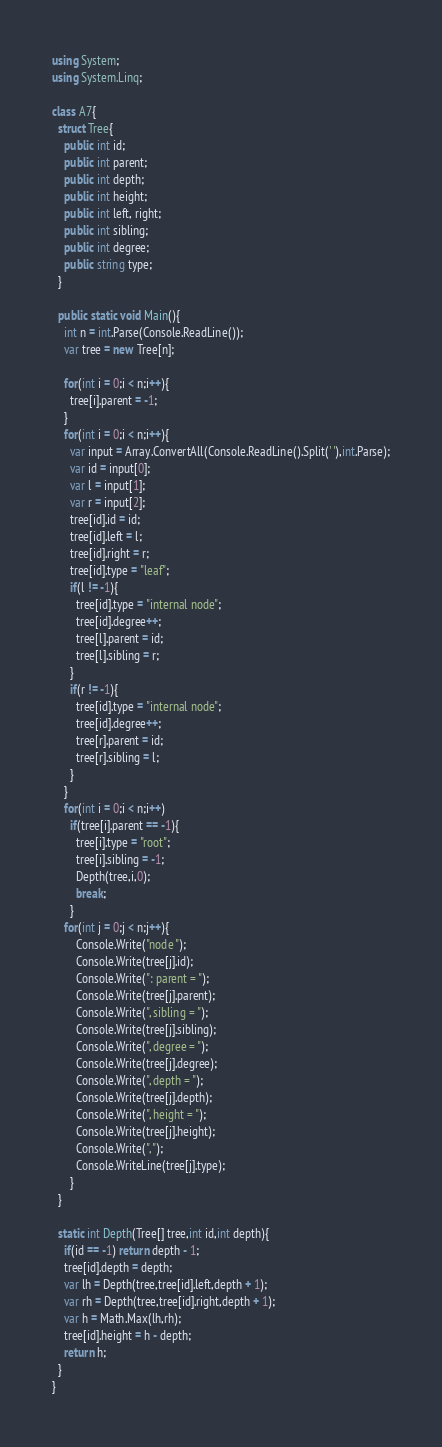Convert code to text. <code><loc_0><loc_0><loc_500><loc_500><_C#_>using System;
using System.Linq;

class A7{
  struct Tree{
    public int id;
    public int parent;
    public int depth;
    public int height;
    public int left, right;
    public int sibling;
    public int degree;
    public string type;
  }

  public static void Main(){
    int n = int.Parse(Console.ReadLine());
    var tree = new Tree[n];

    for(int i = 0;i < n;i++){
      tree[i].parent = -1;
    }
    for(int i = 0;i < n;i++){
      var input = Array.ConvertAll(Console.ReadLine().Split(' '),int.Parse);
      var id = input[0];
      var l = input[1];
      var r = input[2];
      tree[id].id = id;
      tree[id].left = l;
      tree[id].right = r;
      tree[id].type = "leaf";
      if(l != -1){
        tree[id].type = "internal node";
        tree[id].degree++;
        tree[l].parent = id;
        tree[l].sibling = r;
      }
      if(r != -1){
        tree[id].type = "internal node";
        tree[id].degree++;
        tree[r].parent = id;
        tree[r].sibling = l;
      }
    }
    for(int i = 0;i < n;i++)
      if(tree[i].parent == -1){
        tree[i].type = "root";
        tree[i].sibling = -1;
        Depth(tree,i,0);
        break;
      }
    for(int j = 0;j < n;j++){
        Console.Write("node ");
        Console.Write(tree[j].id);
        Console.Write(": parent = ");
        Console.Write(tree[j].parent);
        Console.Write(", sibling = ");
        Console.Write(tree[j].sibling);
        Console.Write(", degree = ");
        Console.Write(tree[j].degree);
        Console.Write(", depth = ");
        Console.Write(tree[j].depth);
        Console.Write(", height = ");
        Console.Write(tree[j].height);
        Console.Write(", ");
        Console.WriteLine(tree[j].type);
      }
  }

  static int Depth(Tree[] tree,int id,int depth){
    if(id == -1) return depth - 1;
    tree[id].depth = depth;
    var lh = Depth(tree,tree[id].left,depth + 1);
    var rh = Depth(tree,tree[id].right,depth + 1);
    var h = Math.Max(lh,rh);
    tree[id].height = h - depth;
    return h;
  }
}
</code> 